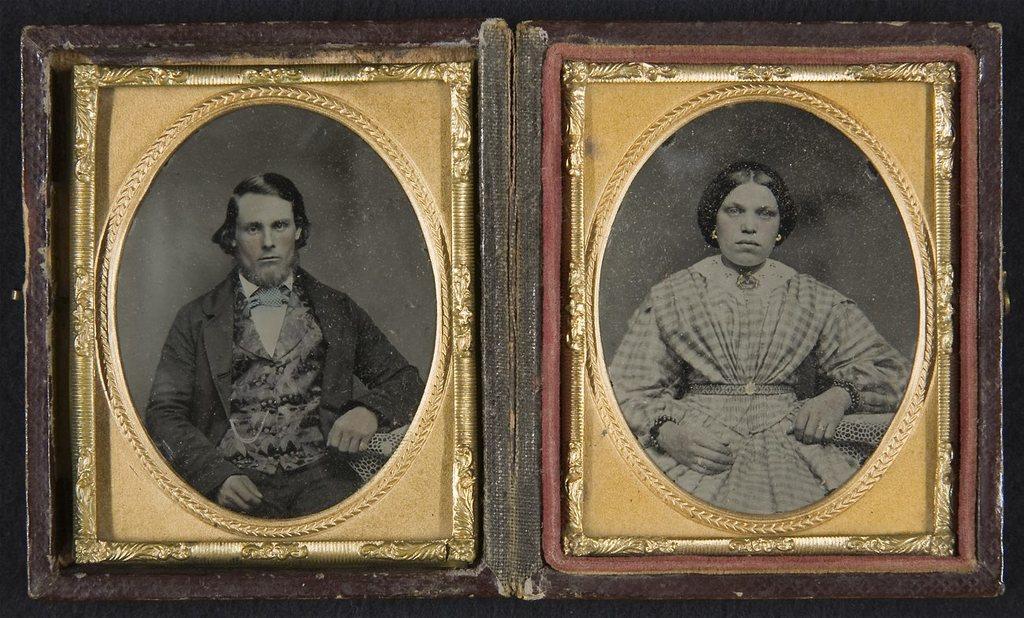In one or two sentences, can you explain what this image depicts? In this picture we can see the photo frames on the surface. 